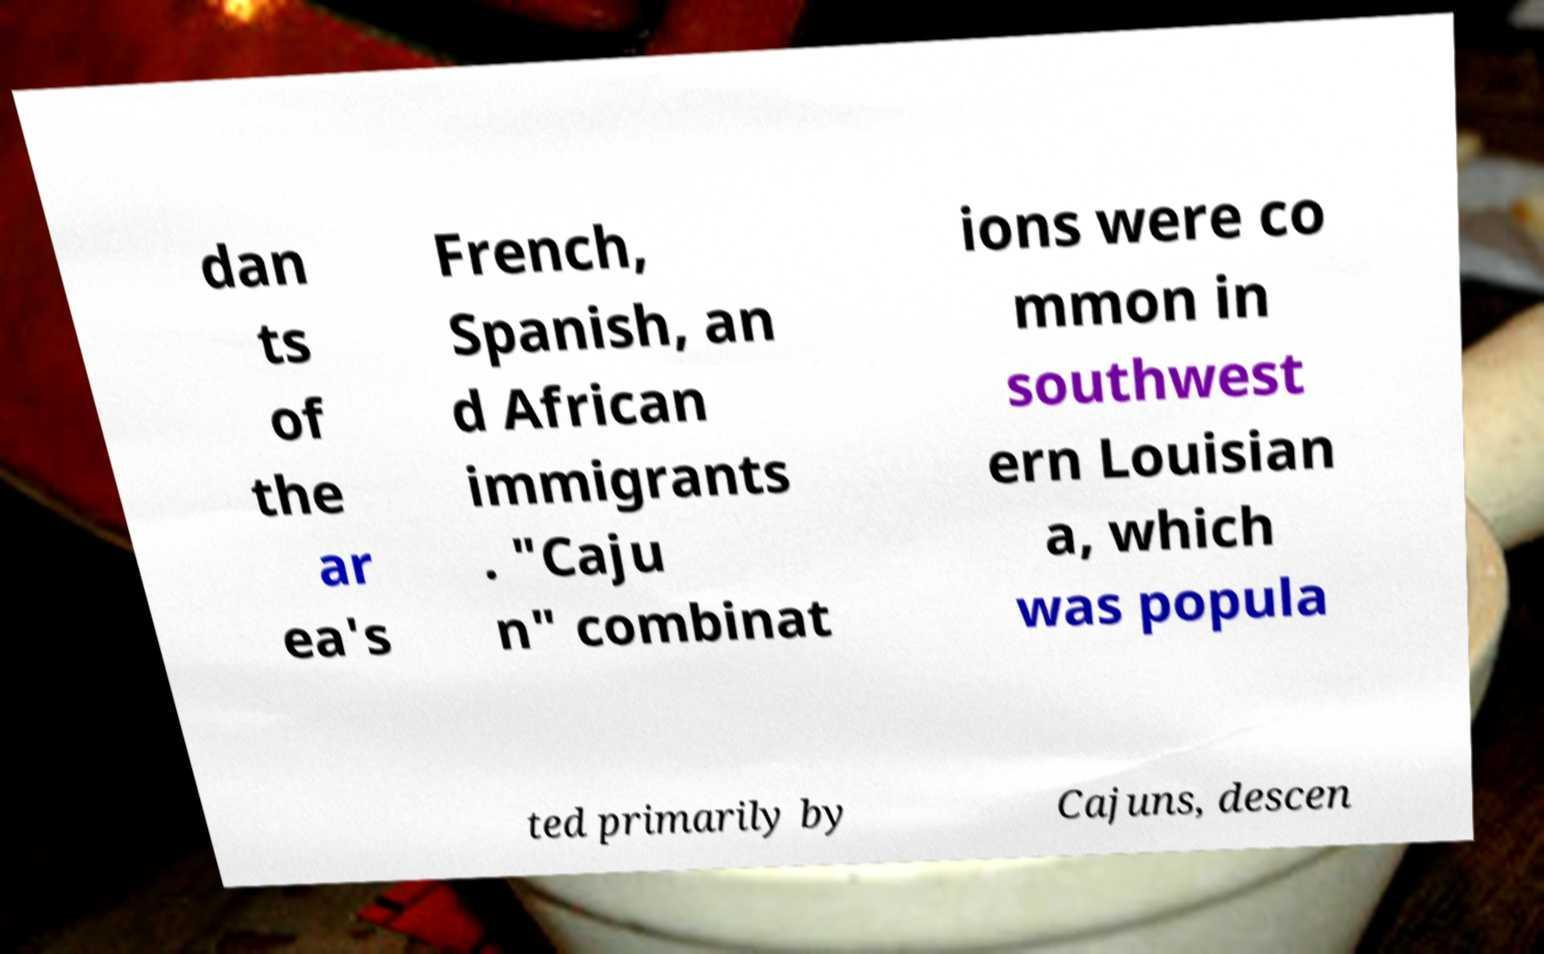Could you assist in decoding the text presented in this image and type it out clearly? dan ts of the ar ea's French, Spanish, an d African immigrants . "Caju n" combinat ions were co mmon in southwest ern Louisian a, which was popula ted primarily by Cajuns, descen 